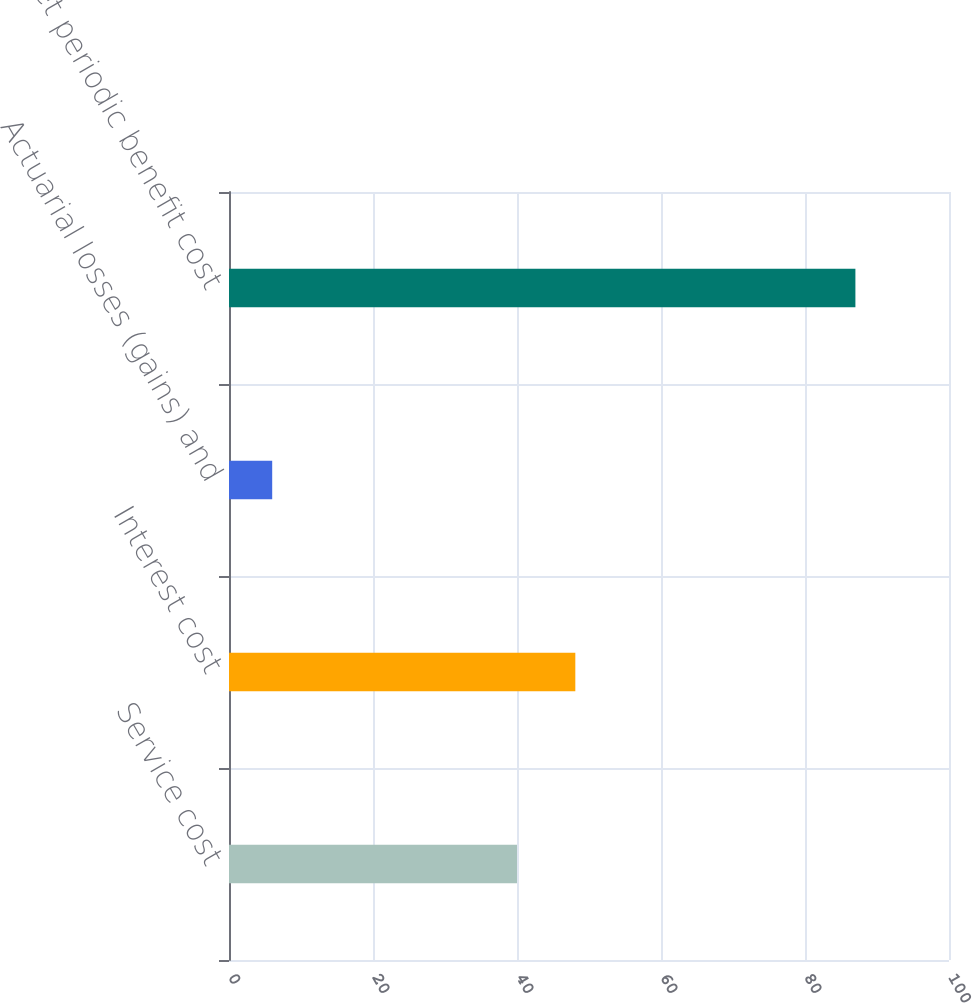Convert chart. <chart><loc_0><loc_0><loc_500><loc_500><bar_chart><fcel>Service cost<fcel>Interest cost<fcel>Actuarial losses (gains) and<fcel>Net periodic benefit cost<nl><fcel>40<fcel>48.1<fcel>6<fcel>87<nl></chart> 